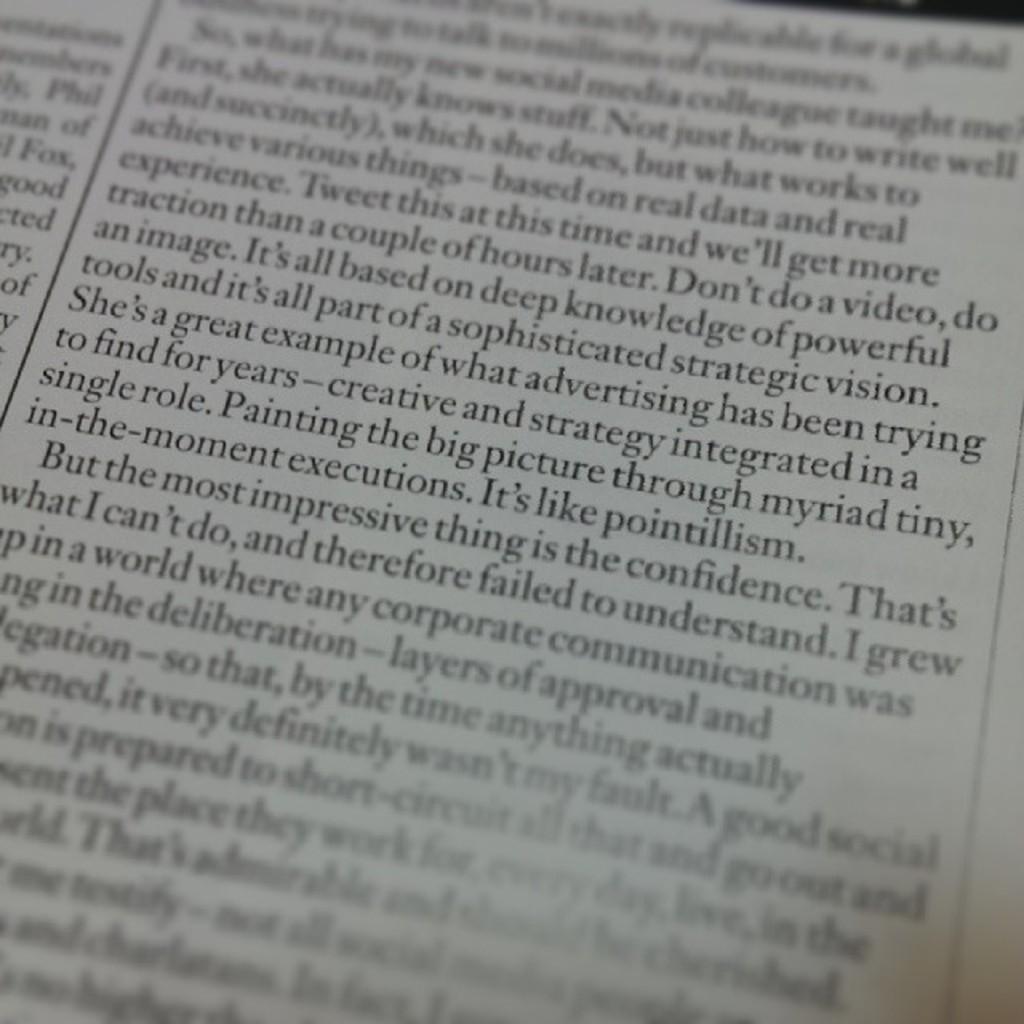In one or two sentences, can you explain what this image depicts? In this image we can see a poster with some text written on it. 